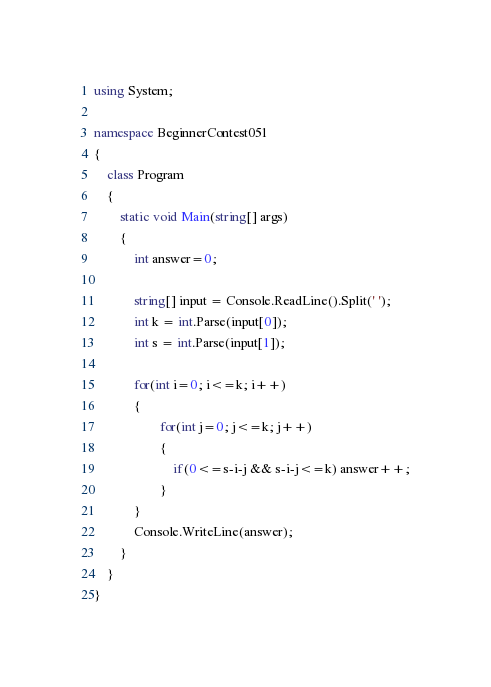<code> <loc_0><loc_0><loc_500><loc_500><_C#_>using System;

namespace BeginnerContest051
{
    class Program
    {
        static void Main(string[] args)
        {
            int answer=0;

            string[] input = Console.ReadLine().Split(' ');
            int k = int.Parse(input[0]);
            int s = int.Parse(input[1]);

            for(int i=0; i<=k; i++)
            {
                    for(int j=0; j<=k; j++)
                    {
                        if(0<=s-i-j && s-i-j<=k) answer++;
                    }
            }
            Console.WriteLine(answer);
        }
    }
}
</code> 